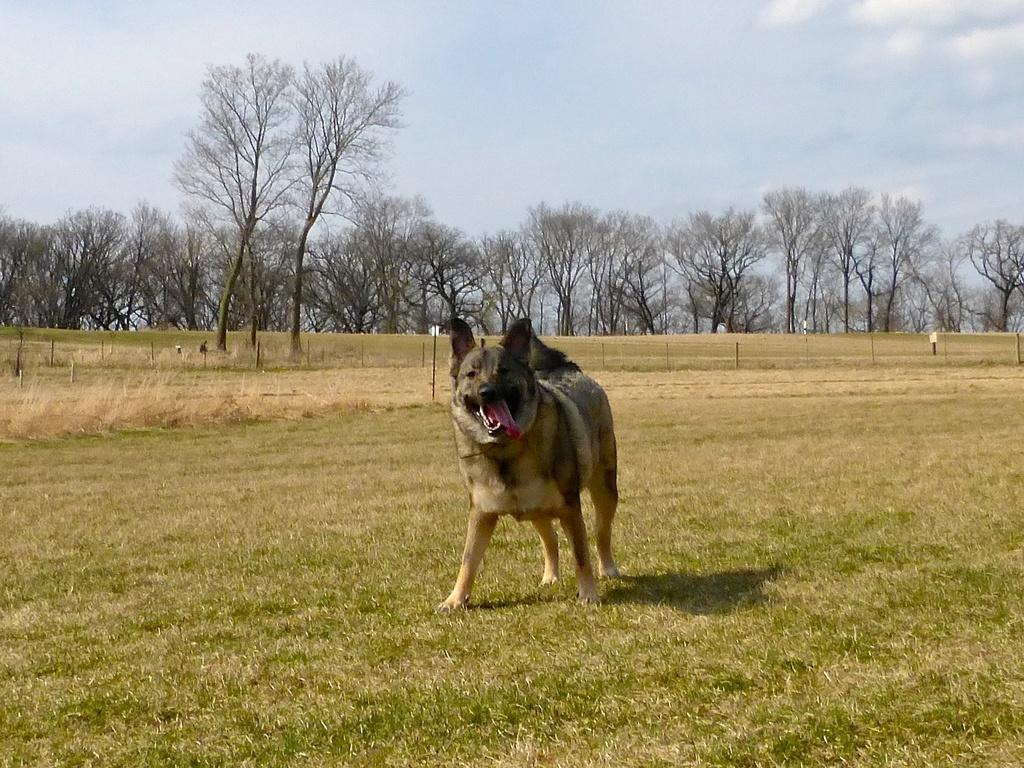What animal is present in the image? There is a dog in the image. Where is the dog located? The dog is on the ground. What can be seen in the background of the image? There is a fence, poles, a group of trees, and a cloudy sky in the background of the image. How many pieces of lumber are stacked next to the dog in the image? There is no lumber present in the image; it only features a dog, a fence, poles, trees, and a cloudy sky in the background. 